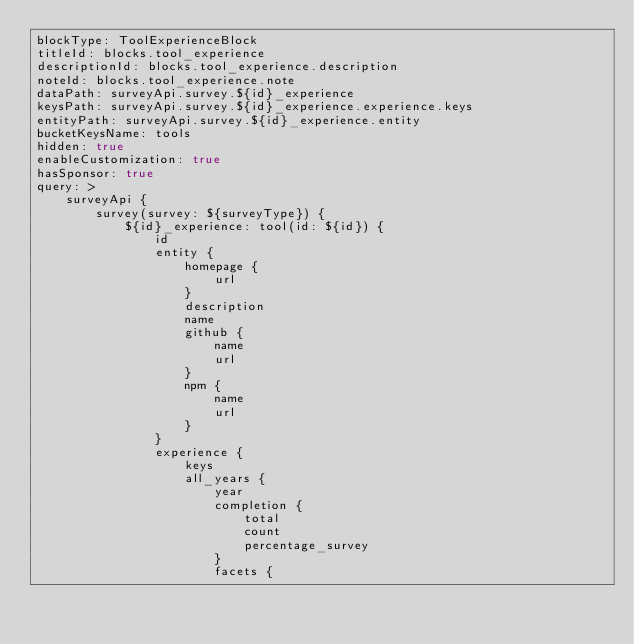<code> <loc_0><loc_0><loc_500><loc_500><_YAML_>blockType: ToolExperienceBlock
titleId: blocks.tool_experience
descriptionId: blocks.tool_experience.description
noteId: blocks.tool_experience.note
dataPath: surveyApi.survey.${id}_experience
keysPath: surveyApi.survey.${id}_experience.experience.keys
entityPath: surveyApi.survey.${id}_experience.entity
bucketKeysName: tools
hidden: true
enableCustomization: true
hasSponsor: true
query: >
    surveyApi {
        survey(survey: ${surveyType}) {
            ${id}_experience: tool(id: ${id}) {
                id
                entity {
                    homepage {
                        url
                    }
                    description
                    name
                    github {
                        name
                        url
                    }
                    npm {
                        name
                        url
                    }
                }
                experience {
                    keys
                    all_years {
                        year
                        completion {
                            total
                            count
                            percentage_survey
                        }
                        facets {</code> 